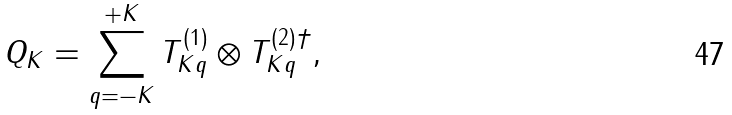Convert formula to latex. <formula><loc_0><loc_0><loc_500><loc_500>Q _ { K } = \sum _ { q = - K } ^ { + K } T ^ { ( 1 ) } _ { K q } \otimes T ^ { ( 2 ) \dagger } _ { K q } ,</formula> 